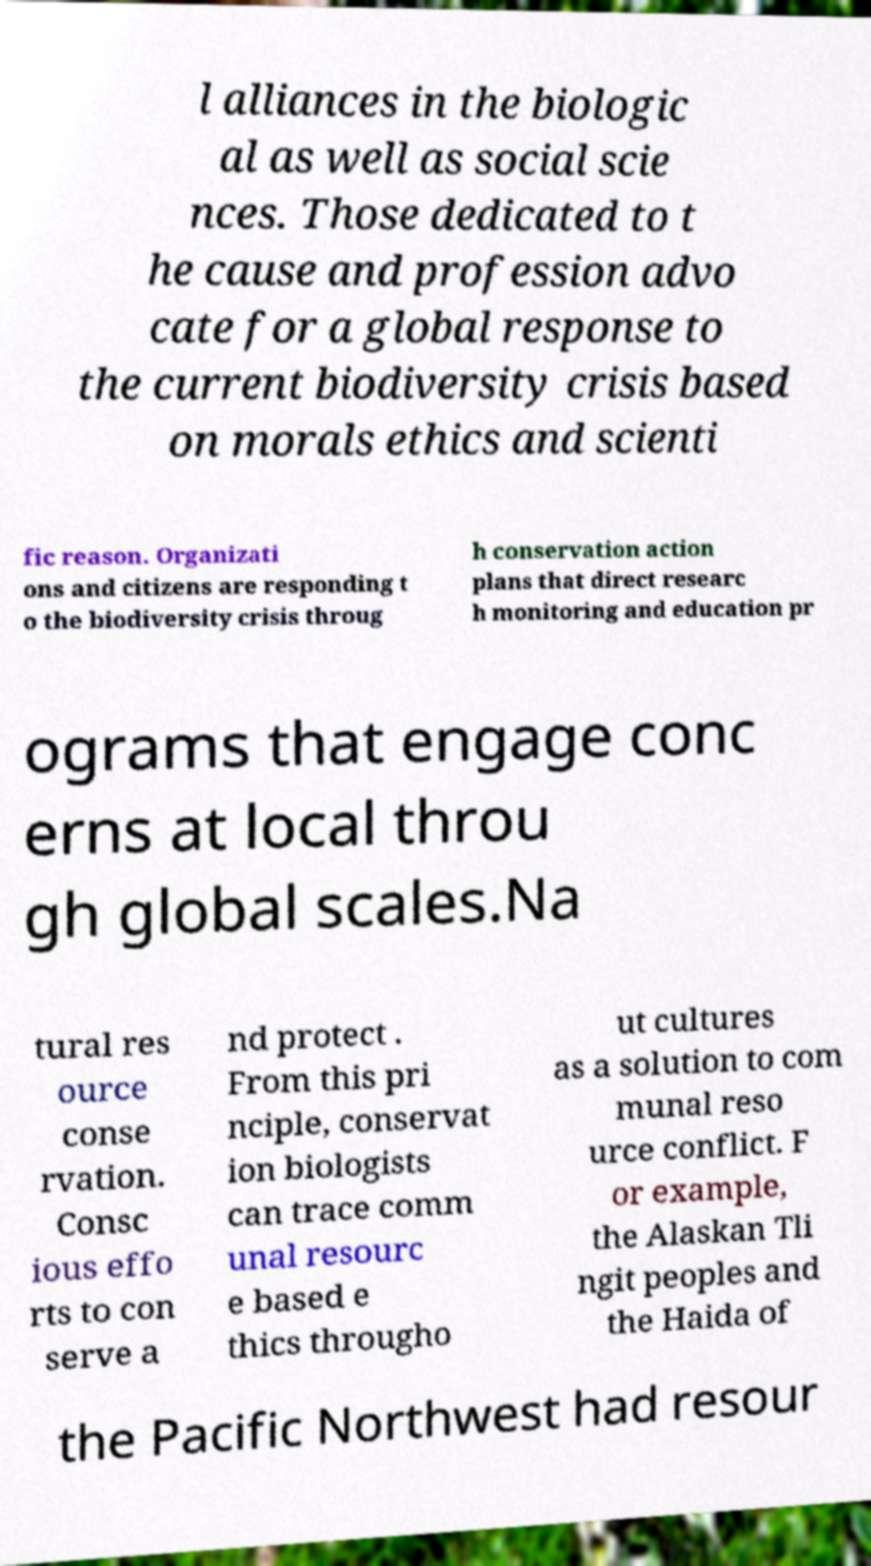Could you assist in decoding the text presented in this image and type it out clearly? l alliances in the biologic al as well as social scie nces. Those dedicated to t he cause and profession advo cate for a global response to the current biodiversity crisis based on morals ethics and scienti fic reason. Organizati ons and citizens are responding t o the biodiversity crisis throug h conservation action plans that direct researc h monitoring and education pr ograms that engage conc erns at local throu gh global scales.Na tural res ource conse rvation. Consc ious effo rts to con serve a nd protect . From this pri nciple, conservat ion biologists can trace comm unal resourc e based e thics througho ut cultures as a solution to com munal reso urce conflict. F or example, the Alaskan Tli ngit peoples and the Haida of the Pacific Northwest had resour 